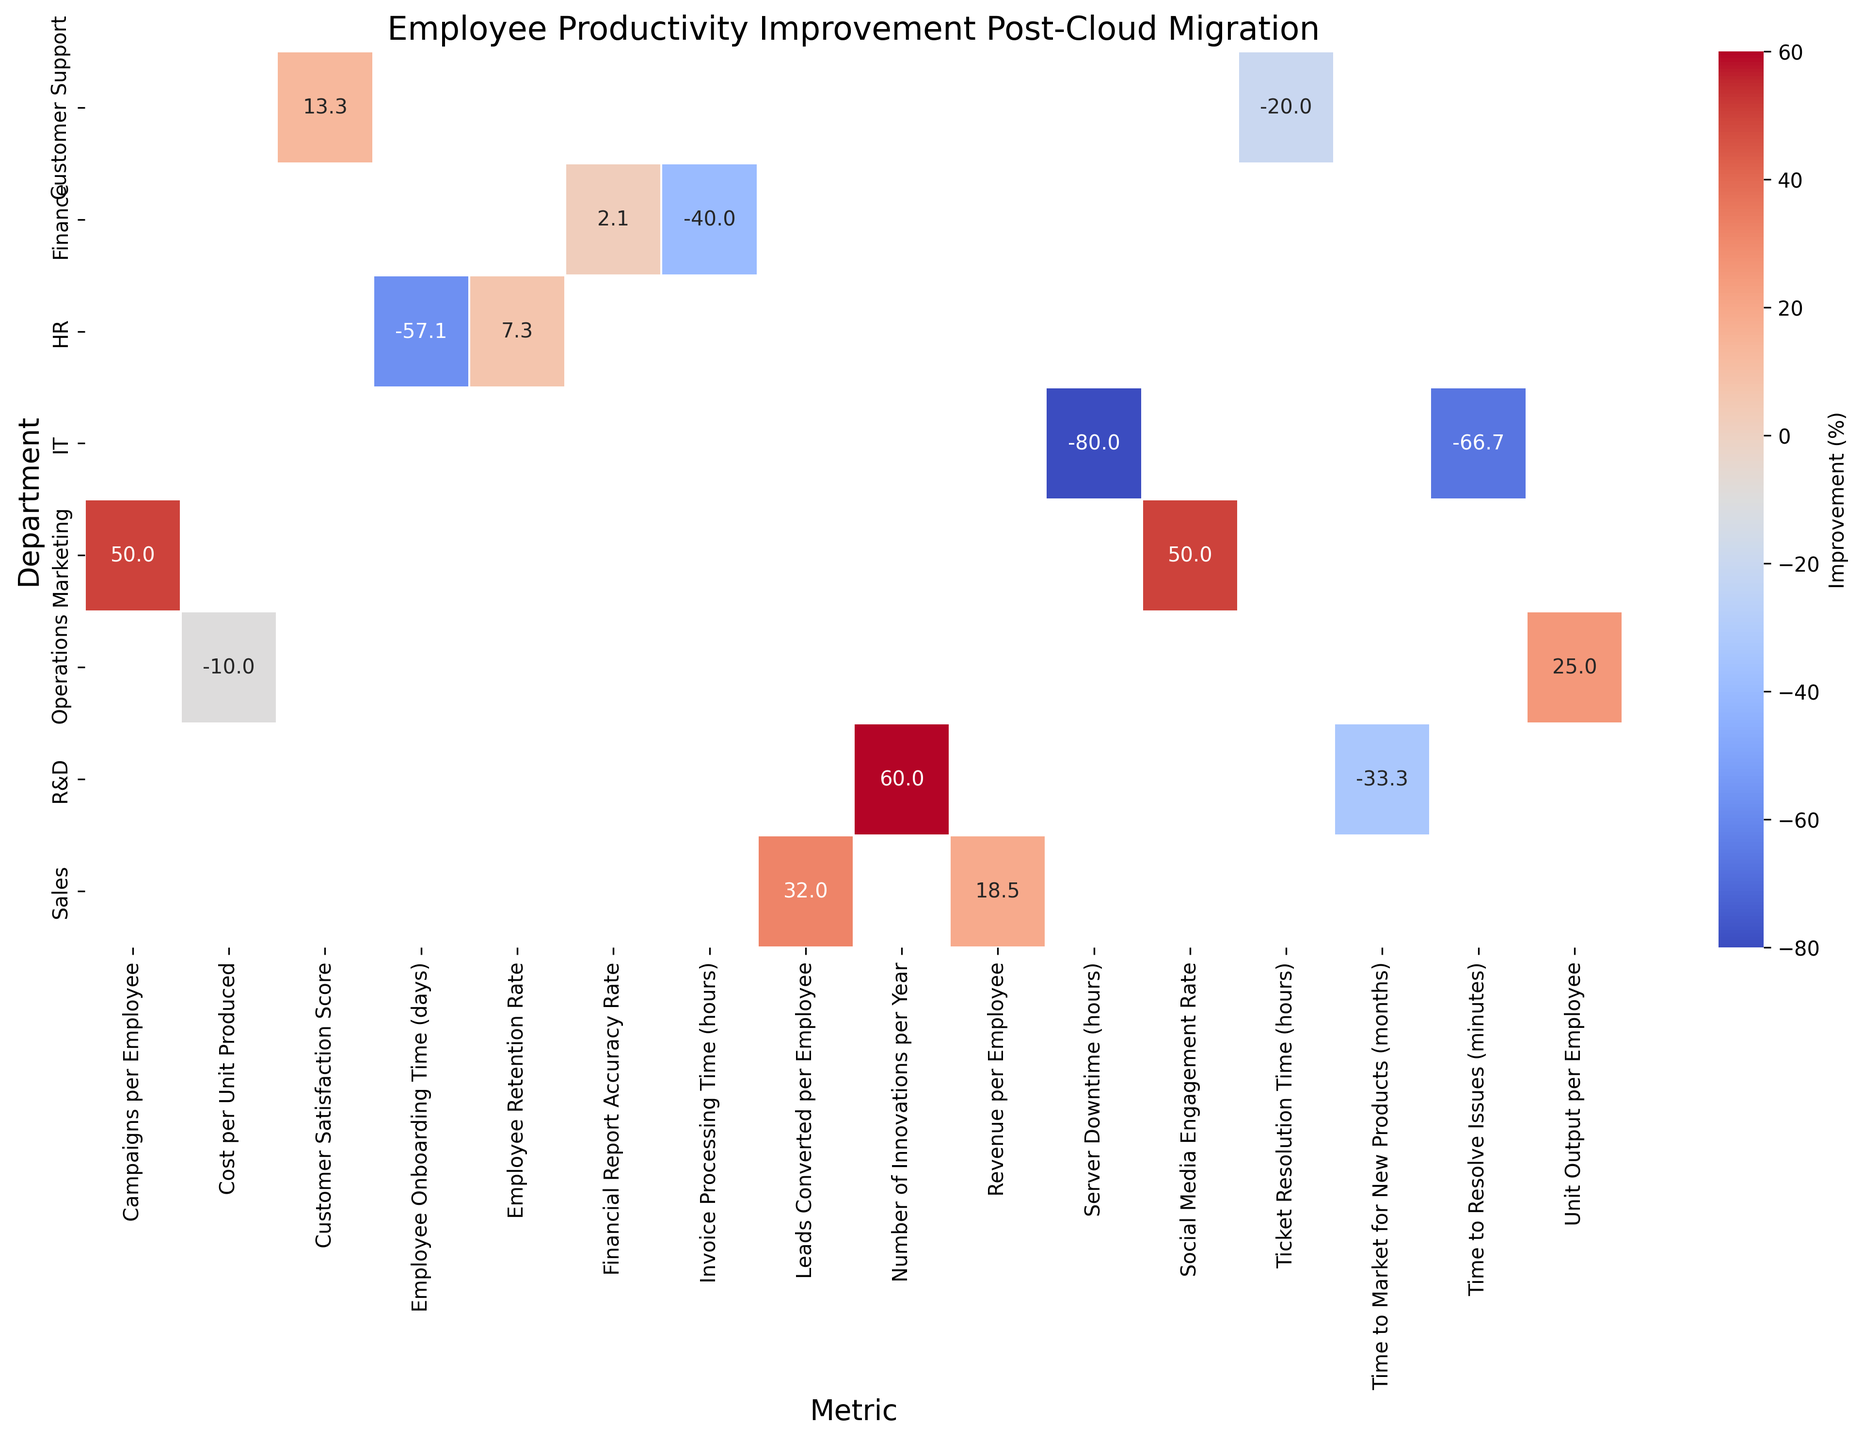Which department shows the highest percentage improvement in any metric post-cloud migration? To find the department with the highest improvement, identify the cell with the highest percentage in the heatmap. Check each cell for the highest percentage value.
Answer: IT Which department had a decrease or no improvement in any metric post-cloud migration? Look for cells with negative or zero values in the heatmap as these indicate a decrease or no improvement.
Answer: No department How much did the "Server Downtime" improve in the IT department post-cloud migration? Locate the cell in the IT department row under the "Server Downtime" column and note the improvement percentage.
Answer: 80% Which department's "Employee Retention Rate" improved the most post-cloud migration? Find the "Employee Retention Rate" metric across all departments and identify which has the highest improvement percentage.
Answer: HR Compare the improvement in "Employee Retention Rate" with "Employee Onboarding Time" in the HR department. Which improved more, and by how much? Look at the improvement percentages for both "Employee Retention Rate" and "Employee Onboarding Time" in the HR department and calculate the difference.
Answer: Employee Onboarding Time improved 210% more than Employee Retention Rate Which metric in the Sales department shows the most improvement? Compare the improvement percentages of "Revenue per Employee" and "Leads Converted per Employee" within the Sales department and identify the higher value.
Answer: Revenue per Employee Was the "Time to Market for New Products" in R&D improved more than "Number of Innovations per Year"? Compare the improvement percentages for both metrics in the R&D department and see which one is higher.
Answer: Yes What is the improvement percentage for the "Invoice Processing Time" metric in the Finance department? Find the cell in the Finance department row under the "Invoice Processing Time" column and read the improvement percentage.
Answer: 40% How does the improvement in "Unit Output per Employee" in Operations compare to the improvement in "Cost per Unit Produced"? Compare the improvement percentages for both metrics in the Operations department and determine the relationship.
Answer: "Unit Output per Employee" improved 25% more than "Cost per Unit Produced" Which metric in the Customer Support department showed the least improvement? Identify the improvement percentages for both "Ticket Resolution Time (hours)" and "Customer Satisfaction Score" in the Customer Support department and pick the lower one.
Answer: Ticket Resolution Time (hours) 